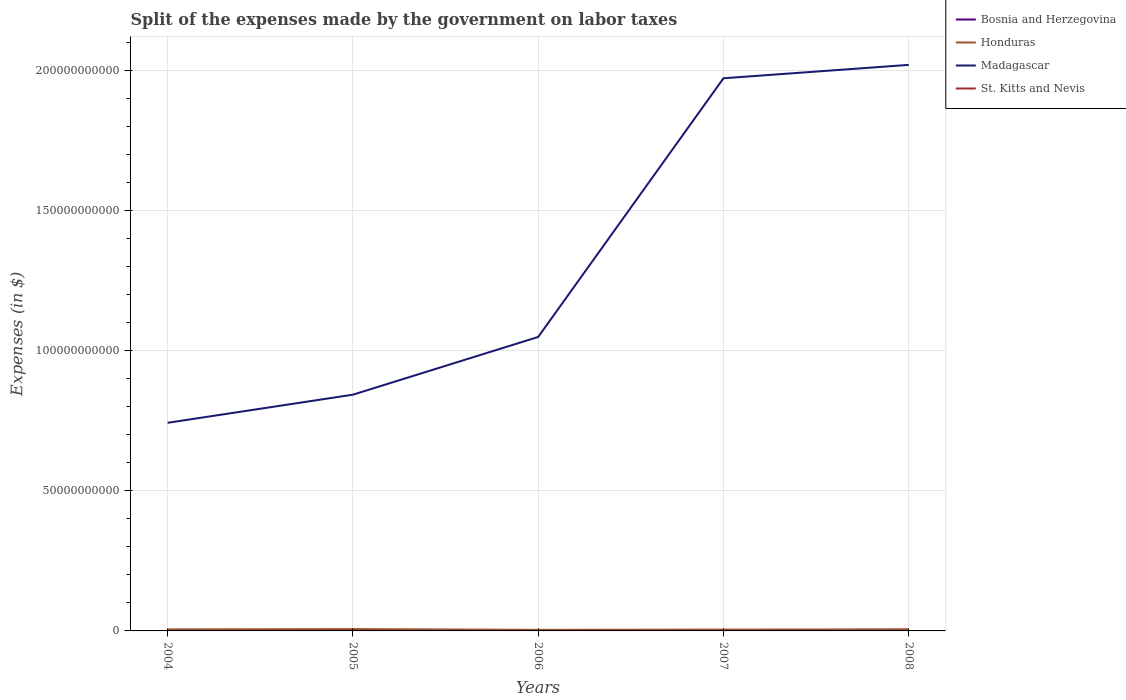Does the line corresponding to Honduras intersect with the line corresponding to Madagascar?
Give a very brief answer. No. Is the number of lines equal to the number of legend labels?
Provide a short and direct response. Yes. Across all years, what is the maximum expenses made by the government on labor taxes in St. Kitts and Nevis?
Your answer should be compact. 5.00e+06. In which year was the expenses made by the government on labor taxes in St. Kitts and Nevis maximum?
Your answer should be compact. 2005. What is the total expenses made by the government on labor taxes in Bosnia and Herzegovina in the graph?
Ensure brevity in your answer.  7.00e+07. What is the difference between the highest and the second highest expenses made by the government on labor taxes in Honduras?
Provide a short and direct response. 2.78e+08. What is the difference between the highest and the lowest expenses made by the government on labor taxes in Honduras?
Your answer should be compact. 3. Is the expenses made by the government on labor taxes in Honduras strictly greater than the expenses made by the government on labor taxes in Madagascar over the years?
Your answer should be very brief. Yes. How many years are there in the graph?
Keep it short and to the point. 5. What is the difference between two consecutive major ticks on the Y-axis?
Make the answer very short. 5.00e+1. Does the graph contain grids?
Give a very brief answer. Yes. How many legend labels are there?
Provide a short and direct response. 4. How are the legend labels stacked?
Your answer should be very brief. Vertical. What is the title of the graph?
Offer a terse response. Split of the expenses made by the government on labor taxes. Does "Zimbabwe" appear as one of the legend labels in the graph?
Offer a very short reply. No. What is the label or title of the X-axis?
Your response must be concise. Years. What is the label or title of the Y-axis?
Keep it short and to the point. Expenses (in $). What is the Expenses (in $) in Bosnia and Herzegovina in 2004?
Keep it short and to the point. 3.19e+08. What is the Expenses (in $) in Honduras in 2004?
Offer a very short reply. 5.48e+08. What is the Expenses (in $) in Madagascar in 2004?
Offer a terse response. 7.43e+1. What is the Expenses (in $) in St. Kitts and Nevis in 2004?
Offer a terse response. 5.10e+06. What is the Expenses (in $) of Bosnia and Herzegovina in 2005?
Your answer should be very brief. 2.79e+08. What is the Expenses (in $) of Honduras in 2005?
Your answer should be very brief. 6.63e+08. What is the Expenses (in $) in Madagascar in 2005?
Provide a short and direct response. 8.43e+1. What is the Expenses (in $) of Bosnia and Herzegovina in 2006?
Keep it short and to the point. 3.04e+08. What is the Expenses (in $) of Honduras in 2006?
Provide a short and direct response. 3.85e+08. What is the Expenses (in $) of Madagascar in 2006?
Your answer should be compact. 1.05e+11. What is the Expenses (in $) of St. Kitts and Nevis in 2006?
Offer a terse response. 8.70e+06. What is the Expenses (in $) in Bosnia and Herzegovina in 2007?
Keep it short and to the point. 2.09e+08. What is the Expenses (in $) in Honduras in 2007?
Provide a short and direct response. 4.78e+08. What is the Expenses (in $) of Madagascar in 2007?
Your answer should be very brief. 1.97e+11. What is the Expenses (in $) of St. Kitts and Nevis in 2007?
Make the answer very short. 7.40e+06. What is the Expenses (in $) in Bosnia and Herzegovina in 2008?
Your answer should be compact. 4.25e+08. What is the Expenses (in $) in Honduras in 2008?
Ensure brevity in your answer.  5.44e+08. What is the Expenses (in $) in Madagascar in 2008?
Provide a succinct answer. 2.02e+11. What is the Expenses (in $) of St. Kitts and Nevis in 2008?
Provide a succinct answer. 6.30e+06. Across all years, what is the maximum Expenses (in $) of Bosnia and Herzegovina?
Make the answer very short. 4.25e+08. Across all years, what is the maximum Expenses (in $) of Honduras?
Your answer should be very brief. 6.63e+08. Across all years, what is the maximum Expenses (in $) of Madagascar?
Offer a terse response. 2.02e+11. Across all years, what is the maximum Expenses (in $) in St. Kitts and Nevis?
Keep it short and to the point. 8.70e+06. Across all years, what is the minimum Expenses (in $) in Bosnia and Herzegovina?
Your answer should be compact. 2.09e+08. Across all years, what is the minimum Expenses (in $) in Honduras?
Ensure brevity in your answer.  3.85e+08. Across all years, what is the minimum Expenses (in $) of Madagascar?
Offer a very short reply. 7.43e+1. What is the total Expenses (in $) of Bosnia and Herzegovina in the graph?
Make the answer very short. 1.54e+09. What is the total Expenses (in $) in Honduras in the graph?
Offer a very short reply. 2.62e+09. What is the total Expenses (in $) in Madagascar in the graph?
Keep it short and to the point. 6.63e+11. What is the total Expenses (in $) in St. Kitts and Nevis in the graph?
Keep it short and to the point. 3.25e+07. What is the difference between the Expenses (in $) in Bosnia and Herzegovina in 2004 and that in 2005?
Offer a terse response. 3.98e+07. What is the difference between the Expenses (in $) in Honduras in 2004 and that in 2005?
Keep it short and to the point. -1.16e+08. What is the difference between the Expenses (in $) of Madagascar in 2004 and that in 2005?
Provide a short and direct response. -1.00e+1. What is the difference between the Expenses (in $) of Bosnia and Herzegovina in 2004 and that in 2006?
Offer a very short reply. 1.43e+07. What is the difference between the Expenses (in $) of Honduras in 2004 and that in 2006?
Your response must be concise. 1.62e+08. What is the difference between the Expenses (in $) in Madagascar in 2004 and that in 2006?
Keep it short and to the point. -3.06e+1. What is the difference between the Expenses (in $) of St. Kitts and Nevis in 2004 and that in 2006?
Offer a terse response. -3.60e+06. What is the difference between the Expenses (in $) in Bosnia and Herzegovina in 2004 and that in 2007?
Your answer should be compact. 1.10e+08. What is the difference between the Expenses (in $) in Honduras in 2004 and that in 2007?
Keep it short and to the point. 6.97e+07. What is the difference between the Expenses (in $) in Madagascar in 2004 and that in 2007?
Ensure brevity in your answer.  -1.23e+11. What is the difference between the Expenses (in $) in St. Kitts and Nevis in 2004 and that in 2007?
Make the answer very short. -2.30e+06. What is the difference between the Expenses (in $) of Bosnia and Herzegovina in 2004 and that in 2008?
Make the answer very short. -1.06e+08. What is the difference between the Expenses (in $) of Honduras in 2004 and that in 2008?
Your answer should be very brief. 3.60e+06. What is the difference between the Expenses (in $) of Madagascar in 2004 and that in 2008?
Your answer should be compact. -1.28e+11. What is the difference between the Expenses (in $) of St. Kitts and Nevis in 2004 and that in 2008?
Provide a succinct answer. -1.20e+06. What is the difference between the Expenses (in $) in Bosnia and Herzegovina in 2005 and that in 2006?
Make the answer very short. -2.55e+07. What is the difference between the Expenses (in $) in Honduras in 2005 and that in 2006?
Offer a very short reply. 2.78e+08. What is the difference between the Expenses (in $) in Madagascar in 2005 and that in 2006?
Give a very brief answer. -2.06e+1. What is the difference between the Expenses (in $) in St. Kitts and Nevis in 2005 and that in 2006?
Offer a very short reply. -3.70e+06. What is the difference between the Expenses (in $) in Bosnia and Herzegovina in 2005 and that in 2007?
Offer a very short reply. 7.00e+07. What is the difference between the Expenses (in $) of Honduras in 2005 and that in 2007?
Your response must be concise. 1.85e+08. What is the difference between the Expenses (in $) in Madagascar in 2005 and that in 2007?
Provide a short and direct response. -1.13e+11. What is the difference between the Expenses (in $) in St. Kitts and Nevis in 2005 and that in 2007?
Your answer should be compact. -2.40e+06. What is the difference between the Expenses (in $) in Bosnia and Herzegovina in 2005 and that in 2008?
Give a very brief answer. -1.46e+08. What is the difference between the Expenses (in $) in Honduras in 2005 and that in 2008?
Offer a terse response. 1.19e+08. What is the difference between the Expenses (in $) of Madagascar in 2005 and that in 2008?
Ensure brevity in your answer.  -1.18e+11. What is the difference between the Expenses (in $) of St. Kitts and Nevis in 2005 and that in 2008?
Offer a very short reply. -1.30e+06. What is the difference between the Expenses (in $) in Bosnia and Herzegovina in 2006 and that in 2007?
Keep it short and to the point. 9.55e+07. What is the difference between the Expenses (in $) in Honduras in 2006 and that in 2007?
Keep it short and to the point. -9.28e+07. What is the difference between the Expenses (in $) of Madagascar in 2006 and that in 2007?
Your response must be concise. -9.23e+1. What is the difference between the Expenses (in $) in St. Kitts and Nevis in 2006 and that in 2007?
Give a very brief answer. 1.30e+06. What is the difference between the Expenses (in $) of Bosnia and Herzegovina in 2006 and that in 2008?
Make the answer very short. -1.21e+08. What is the difference between the Expenses (in $) of Honduras in 2006 and that in 2008?
Your answer should be very brief. -1.59e+08. What is the difference between the Expenses (in $) of Madagascar in 2006 and that in 2008?
Make the answer very short. -9.71e+1. What is the difference between the Expenses (in $) in St. Kitts and Nevis in 2006 and that in 2008?
Offer a very short reply. 2.40e+06. What is the difference between the Expenses (in $) in Bosnia and Herzegovina in 2007 and that in 2008?
Your response must be concise. -2.16e+08. What is the difference between the Expenses (in $) in Honduras in 2007 and that in 2008?
Your answer should be compact. -6.61e+07. What is the difference between the Expenses (in $) of Madagascar in 2007 and that in 2008?
Your answer should be very brief. -4.78e+09. What is the difference between the Expenses (in $) in St. Kitts and Nevis in 2007 and that in 2008?
Your answer should be compact. 1.10e+06. What is the difference between the Expenses (in $) of Bosnia and Herzegovina in 2004 and the Expenses (in $) of Honduras in 2005?
Your answer should be very brief. -3.44e+08. What is the difference between the Expenses (in $) in Bosnia and Herzegovina in 2004 and the Expenses (in $) in Madagascar in 2005?
Ensure brevity in your answer.  -8.40e+1. What is the difference between the Expenses (in $) of Bosnia and Herzegovina in 2004 and the Expenses (in $) of St. Kitts and Nevis in 2005?
Your response must be concise. 3.14e+08. What is the difference between the Expenses (in $) of Honduras in 2004 and the Expenses (in $) of Madagascar in 2005?
Your answer should be very brief. -8.38e+1. What is the difference between the Expenses (in $) of Honduras in 2004 and the Expenses (in $) of St. Kitts and Nevis in 2005?
Provide a short and direct response. 5.42e+08. What is the difference between the Expenses (in $) of Madagascar in 2004 and the Expenses (in $) of St. Kitts and Nevis in 2005?
Provide a succinct answer. 7.43e+1. What is the difference between the Expenses (in $) of Bosnia and Herzegovina in 2004 and the Expenses (in $) of Honduras in 2006?
Offer a very short reply. -6.63e+07. What is the difference between the Expenses (in $) in Bosnia and Herzegovina in 2004 and the Expenses (in $) in Madagascar in 2006?
Provide a succinct answer. -1.05e+11. What is the difference between the Expenses (in $) of Bosnia and Herzegovina in 2004 and the Expenses (in $) of St. Kitts and Nevis in 2006?
Give a very brief answer. 3.10e+08. What is the difference between the Expenses (in $) in Honduras in 2004 and the Expenses (in $) in Madagascar in 2006?
Ensure brevity in your answer.  -1.04e+11. What is the difference between the Expenses (in $) in Honduras in 2004 and the Expenses (in $) in St. Kitts and Nevis in 2006?
Provide a short and direct response. 5.39e+08. What is the difference between the Expenses (in $) in Madagascar in 2004 and the Expenses (in $) in St. Kitts and Nevis in 2006?
Ensure brevity in your answer.  7.43e+1. What is the difference between the Expenses (in $) in Bosnia and Herzegovina in 2004 and the Expenses (in $) in Honduras in 2007?
Offer a terse response. -1.59e+08. What is the difference between the Expenses (in $) in Bosnia and Herzegovina in 2004 and the Expenses (in $) in Madagascar in 2007?
Ensure brevity in your answer.  -1.97e+11. What is the difference between the Expenses (in $) in Bosnia and Herzegovina in 2004 and the Expenses (in $) in St. Kitts and Nevis in 2007?
Provide a succinct answer. 3.11e+08. What is the difference between the Expenses (in $) of Honduras in 2004 and the Expenses (in $) of Madagascar in 2007?
Make the answer very short. -1.97e+11. What is the difference between the Expenses (in $) in Honduras in 2004 and the Expenses (in $) in St. Kitts and Nevis in 2007?
Provide a succinct answer. 5.40e+08. What is the difference between the Expenses (in $) in Madagascar in 2004 and the Expenses (in $) in St. Kitts and Nevis in 2007?
Provide a succinct answer. 7.43e+1. What is the difference between the Expenses (in $) of Bosnia and Herzegovina in 2004 and the Expenses (in $) of Honduras in 2008?
Offer a very short reply. -2.25e+08. What is the difference between the Expenses (in $) in Bosnia and Herzegovina in 2004 and the Expenses (in $) in Madagascar in 2008?
Provide a short and direct response. -2.02e+11. What is the difference between the Expenses (in $) in Bosnia and Herzegovina in 2004 and the Expenses (in $) in St. Kitts and Nevis in 2008?
Your answer should be compact. 3.12e+08. What is the difference between the Expenses (in $) in Honduras in 2004 and the Expenses (in $) in Madagascar in 2008?
Offer a terse response. -2.01e+11. What is the difference between the Expenses (in $) in Honduras in 2004 and the Expenses (in $) in St. Kitts and Nevis in 2008?
Your answer should be very brief. 5.41e+08. What is the difference between the Expenses (in $) of Madagascar in 2004 and the Expenses (in $) of St. Kitts and Nevis in 2008?
Provide a succinct answer. 7.43e+1. What is the difference between the Expenses (in $) in Bosnia and Herzegovina in 2005 and the Expenses (in $) in Honduras in 2006?
Provide a succinct answer. -1.06e+08. What is the difference between the Expenses (in $) in Bosnia and Herzegovina in 2005 and the Expenses (in $) in Madagascar in 2006?
Give a very brief answer. -1.05e+11. What is the difference between the Expenses (in $) of Bosnia and Herzegovina in 2005 and the Expenses (in $) of St. Kitts and Nevis in 2006?
Your answer should be very brief. 2.70e+08. What is the difference between the Expenses (in $) of Honduras in 2005 and the Expenses (in $) of Madagascar in 2006?
Offer a very short reply. -1.04e+11. What is the difference between the Expenses (in $) of Honduras in 2005 and the Expenses (in $) of St. Kitts and Nevis in 2006?
Your answer should be very brief. 6.54e+08. What is the difference between the Expenses (in $) of Madagascar in 2005 and the Expenses (in $) of St. Kitts and Nevis in 2006?
Your response must be concise. 8.43e+1. What is the difference between the Expenses (in $) of Bosnia and Herzegovina in 2005 and the Expenses (in $) of Honduras in 2007?
Offer a terse response. -1.99e+08. What is the difference between the Expenses (in $) in Bosnia and Herzegovina in 2005 and the Expenses (in $) in Madagascar in 2007?
Make the answer very short. -1.97e+11. What is the difference between the Expenses (in $) of Bosnia and Herzegovina in 2005 and the Expenses (in $) of St. Kitts and Nevis in 2007?
Provide a short and direct response. 2.72e+08. What is the difference between the Expenses (in $) in Honduras in 2005 and the Expenses (in $) in Madagascar in 2007?
Offer a terse response. -1.97e+11. What is the difference between the Expenses (in $) of Honduras in 2005 and the Expenses (in $) of St. Kitts and Nevis in 2007?
Offer a very short reply. 6.56e+08. What is the difference between the Expenses (in $) of Madagascar in 2005 and the Expenses (in $) of St. Kitts and Nevis in 2007?
Keep it short and to the point. 8.43e+1. What is the difference between the Expenses (in $) of Bosnia and Herzegovina in 2005 and the Expenses (in $) of Honduras in 2008?
Offer a very short reply. -2.65e+08. What is the difference between the Expenses (in $) of Bosnia and Herzegovina in 2005 and the Expenses (in $) of Madagascar in 2008?
Your answer should be compact. -2.02e+11. What is the difference between the Expenses (in $) of Bosnia and Herzegovina in 2005 and the Expenses (in $) of St. Kitts and Nevis in 2008?
Provide a succinct answer. 2.73e+08. What is the difference between the Expenses (in $) of Honduras in 2005 and the Expenses (in $) of Madagascar in 2008?
Give a very brief answer. -2.01e+11. What is the difference between the Expenses (in $) in Honduras in 2005 and the Expenses (in $) in St. Kitts and Nevis in 2008?
Offer a very short reply. 6.57e+08. What is the difference between the Expenses (in $) in Madagascar in 2005 and the Expenses (in $) in St. Kitts and Nevis in 2008?
Give a very brief answer. 8.43e+1. What is the difference between the Expenses (in $) of Bosnia and Herzegovina in 2006 and the Expenses (in $) of Honduras in 2007?
Your answer should be compact. -1.73e+08. What is the difference between the Expenses (in $) in Bosnia and Herzegovina in 2006 and the Expenses (in $) in Madagascar in 2007?
Your answer should be very brief. -1.97e+11. What is the difference between the Expenses (in $) in Bosnia and Herzegovina in 2006 and the Expenses (in $) in St. Kitts and Nevis in 2007?
Offer a terse response. 2.97e+08. What is the difference between the Expenses (in $) in Honduras in 2006 and the Expenses (in $) in Madagascar in 2007?
Provide a succinct answer. -1.97e+11. What is the difference between the Expenses (in $) of Honduras in 2006 and the Expenses (in $) of St. Kitts and Nevis in 2007?
Your answer should be compact. 3.78e+08. What is the difference between the Expenses (in $) in Madagascar in 2006 and the Expenses (in $) in St. Kitts and Nevis in 2007?
Provide a short and direct response. 1.05e+11. What is the difference between the Expenses (in $) of Bosnia and Herzegovina in 2006 and the Expenses (in $) of Honduras in 2008?
Offer a terse response. -2.39e+08. What is the difference between the Expenses (in $) in Bosnia and Herzegovina in 2006 and the Expenses (in $) in Madagascar in 2008?
Make the answer very short. -2.02e+11. What is the difference between the Expenses (in $) in Bosnia and Herzegovina in 2006 and the Expenses (in $) in St. Kitts and Nevis in 2008?
Ensure brevity in your answer.  2.98e+08. What is the difference between the Expenses (in $) of Honduras in 2006 and the Expenses (in $) of Madagascar in 2008?
Offer a very short reply. -2.02e+11. What is the difference between the Expenses (in $) in Honduras in 2006 and the Expenses (in $) in St. Kitts and Nevis in 2008?
Keep it short and to the point. 3.79e+08. What is the difference between the Expenses (in $) of Madagascar in 2006 and the Expenses (in $) of St. Kitts and Nevis in 2008?
Your answer should be very brief. 1.05e+11. What is the difference between the Expenses (in $) of Bosnia and Herzegovina in 2007 and the Expenses (in $) of Honduras in 2008?
Your response must be concise. -3.35e+08. What is the difference between the Expenses (in $) in Bosnia and Herzegovina in 2007 and the Expenses (in $) in Madagascar in 2008?
Keep it short and to the point. -2.02e+11. What is the difference between the Expenses (in $) in Bosnia and Herzegovina in 2007 and the Expenses (in $) in St. Kitts and Nevis in 2008?
Your answer should be compact. 2.03e+08. What is the difference between the Expenses (in $) in Honduras in 2007 and the Expenses (in $) in Madagascar in 2008?
Give a very brief answer. -2.02e+11. What is the difference between the Expenses (in $) in Honduras in 2007 and the Expenses (in $) in St. Kitts and Nevis in 2008?
Your answer should be compact. 4.72e+08. What is the difference between the Expenses (in $) of Madagascar in 2007 and the Expenses (in $) of St. Kitts and Nevis in 2008?
Provide a short and direct response. 1.97e+11. What is the average Expenses (in $) of Bosnia and Herzegovina per year?
Your response must be concise. 3.07e+08. What is the average Expenses (in $) of Honduras per year?
Offer a terse response. 5.23e+08. What is the average Expenses (in $) of Madagascar per year?
Give a very brief answer. 1.33e+11. What is the average Expenses (in $) of St. Kitts and Nevis per year?
Offer a terse response. 6.50e+06. In the year 2004, what is the difference between the Expenses (in $) of Bosnia and Herzegovina and Expenses (in $) of Honduras?
Your answer should be compact. -2.29e+08. In the year 2004, what is the difference between the Expenses (in $) in Bosnia and Herzegovina and Expenses (in $) in Madagascar?
Your answer should be very brief. -7.39e+1. In the year 2004, what is the difference between the Expenses (in $) of Bosnia and Herzegovina and Expenses (in $) of St. Kitts and Nevis?
Provide a short and direct response. 3.14e+08. In the year 2004, what is the difference between the Expenses (in $) of Honduras and Expenses (in $) of Madagascar?
Offer a very short reply. -7.37e+1. In the year 2004, what is the difference between the Expenses (in $) of Honduras and Expenses (in $) of St. Kitts and Nevis?
Your answer should be very brief. 5.42e+08. In the year 2004, what is the difference between the Expenses (in $) of Madagascar and Expenses (in $) of St. Kitts and Nevis?
Your answer should be very brief. 7.43e+1. In the year 2005, what is the difference between the Expenses (in $) in Bosnia and Herzegovina and Expenses (in $) in Honduras?
Keep it short and to the point. -3.84e+08. In the year 2005, what is the difference between the Expenses (in $) of Bosnia and Herzegovina and Expenses (in $) of Madagascar?
Provide a succinct answer. -8.40e+1. In the year 2005, what is the difference between the Expenses (in $) of Bosnia and Herzegovina and Expenses (in $) of St. Kitts and Nevis?
Offer a very short reply. 2.74e+08. In the year 2005, what is the difference between the Expenses (in $) of Honduras and Expenses (in $) of Madagascar?
Your answer should be very brief. -8.36e+1. In the year 2005, what is the difference between the Expenses (in $) in Honduras and Expenses (in $) in St. Kitts and Nevis?
Ensure brevity in your answer.  6.58e+08. In the year 2005, what is the difference between the Expenses (in $) of Madagascar and Expenses (in $) of St. Kitts and Nevis?
Your answer should be compact. 8.43e+1. In the year 2006, what is the difference between the Expenses (in $) of Bosnia and Herzegovina and Expenses (in $) of Honduras?
Ensure brevity in your answer.  -8.05e+07. In the year 2006, what is the difference between the Expenses (in $) in Bosnia and Herzegovina and Expenses (in $) in Madagascar?
Keep it short and to the point. -1.05e+11. In the year 2006, what is the difference between the Expenses (in $) in Bosnia and Herzegovina and Expenses (in $) in St. Kitts and Nevis?
Offer a very short reply. 2.96e+08. In the year 2006, what is the difference between the Expenses (in $) of Honduras and Expenses (in $) of Madagascar?
Provide a succinct answer. -1.05e+11. In the year 2006, what is the difference between the Expenses (in $) of Honduras and Expenses (in $) of St. Kitts and Nevis?
Offer a very short reply. 3.76e+08. In the year 2006, what is the difference between the Expenses (in $) in Madagascar and Expenses (in $) in St. Kitts and Nevis?
Provide a short and direct response. 1.05e+11. In the year 2007, what is the difference between the Expenses (in $) of Bosnia and Herzegovina and Expenses (in $) of Honduras?
Your response must be concise. -2.69e+08. In the year 2007, what is the difference between the Expenses (in $) of Bosnia and Herzegovina and Expenses (in $) of Madagascar?
Offer a terse response. -1.97e+11. In the year 2007, what is the difference between the Expenses (in $) of Bosnia and Herzegovina and Expenses (in $) of St. Kitts and Nevis?
Provide a succinct answer. 2.02e+08. In the year 2007, what is the difference between the Expenses (in $) in Honduras and Expenses (in $) in Madagascar?
Offer a very short reply. -1.97e+11. In the year 2007, what is the difference between the Expenses (in $) in Honduras and Expenses (in $) in St. Kitts and Nevis?
Make the answer very short. 4.70e+08. In the year 2007, what is the difference between the Expenses (in $) of Madagascar and Expenses (in $) of St. Kitts and Nevis?
Give a very brief answer. 1.97e+11. In the year 2008, what is the difference between the Expenses (in $) of Bosnia and Herzegovina and Expenses (in $) of Honduras?
Your response must be concise. -1.19e+08. In the year 2008, what is the difference between the Expenses (in $) in Bosnia and Herzegovina and Expenses (in $) in Madagascar?
Your response must be concise. -2.02e+11. In the year 2008, what is the difference between the Expenses (in $) in Bosnia and Herzegovina and Expenses (in $) in St. Kitts and Nevis?
Give a very brief answer. 4.19e+08. In the year 2008, what is the difference between the Expenses (in $) in Honduras and Expenses (in $) in Madagascar?
Your answer should be compact. -2.01e+11. In the year 2008, what is the difference between the Expenses (in $) of Honduras and Expenses (in $) of St. Kitts and Nevis?
Ensure brevity in your answer.  5.38e+08. In the year 2008, what is the difference between the Expenses (in $) in Madagascar and Expenses (in $) in St. Kitts and Nevis?
Offer a very short reply. 2.02e+11. What is the ratio of the Expenses (in $) in Bosnia and Herzegovina in 2004 to that in 2005?
Your response must be concise. 1.14. What is the ratio of the Expenses (in $) of Honduras in 2004 to that in 2005?
Your answer should be very brief. 0.83. What is the ratio of the Expenses (in $) of Madagascar in 2004 to that in 2005?
Keep it short and to the point. 0.88. What is the ratio of the Expenses (in $) in St. Kitts and Nevis in 2004 to that in 2005?
Provide a succinct answer. 1.02. What is the ratio of the Expenses (in $) of Bosnia and Herzegovina in 2004 to that in 2006?
Keep it short and to the point. 1.05. What is the ratio of the Expenses (in $) in Honduras in 2004 to that in 2006?
Offer a terse response. 1.42. What is the ratio of the Expenses (in $) of Madagascar in 2004 to that in 2006?
Ensure brevity in your answer.  0.71. What is the ratio of the Expenses (in $) in St. Kitts and Nevis in 2004 to that in 2006?
Ensure brevity in your answer.  0.59. What is the ratio of the Expenses (in $) of Bosnia and Herzegovina in 2004 to that in 2007?
Your answer should be very brief. 1.53. What is the ratio of the Expenses (in $) of Honduras in 2004 to that in 2007?
Your response must be concise. 1.15. What is the ratio of the Expenses (in $) of Madagascar in 2004 to that in 2007?
Offer a terse response. 0.38. What is the ratio of the Expenses (in $) in St. Kitts and Nevis in 2004 to that in 2007?
Provide a short and direct response. 0.69. What is the ratio of the Expenses (in $) of Bosnia and Herzegovina in 2004 to that in 2008?
Your response must be concise. 0.75. What is the ratio of the Expenses (in $) in Honduras in 2004 to that in 2008?
Provide a short and direct response. 1.01. What is the ratio of the Expenses (in $) of Madagascar in 2004 to that in 2008?
Offer a terse response. 0.37. What is the ratio of the Expenses (in $) in St. Kitts and Nevis in 2004 to that in 2008?
Provide a succinct answer. 0.81. What is the ratio of the Expenses (in $) in Bosnia and Herzegovina in 2005 to that in 2006?
Your response must be concise. 0.92. What is the ratio of the Expenses (in $) in Honduras in 2005 to that in 2006?
Your answer should be compact. 1.72. What is the ratio of the Expenses (in $) of Madagascar in 2005 to that in 2006?
Your answer should be compact. 0.8. What is the ratio of the Expenses (in $) of St. Kitts and Nevis in 2005 to that in 2006?
Your answer should be compact. 0.57. What is the ratio of the Expenses (in $) in Bosnia and Herzegovina in 2005 to that in 2007?
Offer a very short reply. 1.34. What is the ratio of the Expenses (in $) in Honduras in 2005 to that in 2007?
Your answer should be compact. 1.39. What is the ratio of the Expenses (in $) of Madagascar in 2005 to that in 2007?
Make the answer very short. 0.43. What is the ratio of the Expenses (in $) in St. Kitts and Nevis in 2005 to that in 2007?
Offer a terse response. 0.68. What is the ratio of the Expenses (in $) in Bosnia and Herzegovina in 2005 to that in 2008?
Offer a terse response. 0.66. What is the ratio of the Expenses (in $) of Honduras in 2005 to that in 2008?
Your response must be concise. 1.22. What is the ratio of the Expenses (in $) of Madagascar in 2005 to that in 2008?
Make the answer very short. 0.42. What is the ratio of the Expenses (in $) of St. Kitts and Nevis in 2005 to that in 2008?
Give a very brief answer. 0.79. What is the ratio of the Expenses (in $) in Bosnia and Herzegovina in 2006 to that in 2007?
Your answer should be compact. 1.46. What is the ratio of the Expenses (in $) in Honduras in 2006 to that in 2007?
Your answer should be compact. 0.81. What is the ratio of the Expenses (in $) of Madagascar in 2006 to that in 2007?
Your answer should be compact. 0.53. What is the ratio of the Expenses (in $) of St. Kitts and Nevis in 2006 to that in 2007?
Give a very brief answer. 1.18. What is the ratio of the Expenses (in $) of Bosnia and Herzegovina in 2006 to that in 2008?
Your answer should be very brief. 0.72. What is the ratio of the Expenses (in $) of Honduras in 2006 to that in 2008?
Provide a succinct answer. 0.71. What is the ratio of the Expenses (in $) in Madagascar in 2006 to that in 2008?
Make the answer very short. 0.52. What is the ratio of the Expenses (in $) of St. Kitts and Nevis in 2006 to that in 2008?
Keep it short and to the point. 1.38. What is the ratio of the Expenses (in $) of Bosnia and Herzegovina in 2007 to that in 2008?
Your answer should be very brief. 0.49. What is the ratio of the Expenses (in $) of Honduras in 2007 to that in 2008?
Provide a short and direct response. 0.88. What is the ratio of the Expenses (in $) of Madagascar in 2007 to that in 2008?
Keep it short and to the point. 0.98. What is the ratio of the Expenses (in $) of St. Kitts and Nevis in 2007 to that in 2008?
Your answer should be very brief. 1.17. What is the difference between the highest and the second highest Expenses (in $) of Bosnia and Herzegovina?
Make the answer very short. 1.06e+08. What is the difference between the highest and the second highest Expenses (in $) of Honduras?
Your response must be concise. 1.16e+08. What is the difference between the highest and the second highest Expenses (in $) in Madagascar?
Make the answer very short. 4.78e+09. What is the difference between the highest and the second highest Expenses (in $) in St. Kitts and Nevis?
Give a very brief answer. 1.30e+06. What is the difference between the highest and the lowest Expenses (in $) in Bosnia and Herzegovina?
Give a very brief answer. 2.16e+08. What is the difference between the highest and the lowest Expenses (in $) of Honduras?
Your answer should be very brief. 2.78e+08. What is the difference between the highest and the lowest Expenses (in $) in Madagascar?
Your response must be concise. 1.28e+11. What is the difference between the highest and the lowest Expenses (in $) of St. Kitts and Nevis?
Your response must be concise. 3.70e+06. 